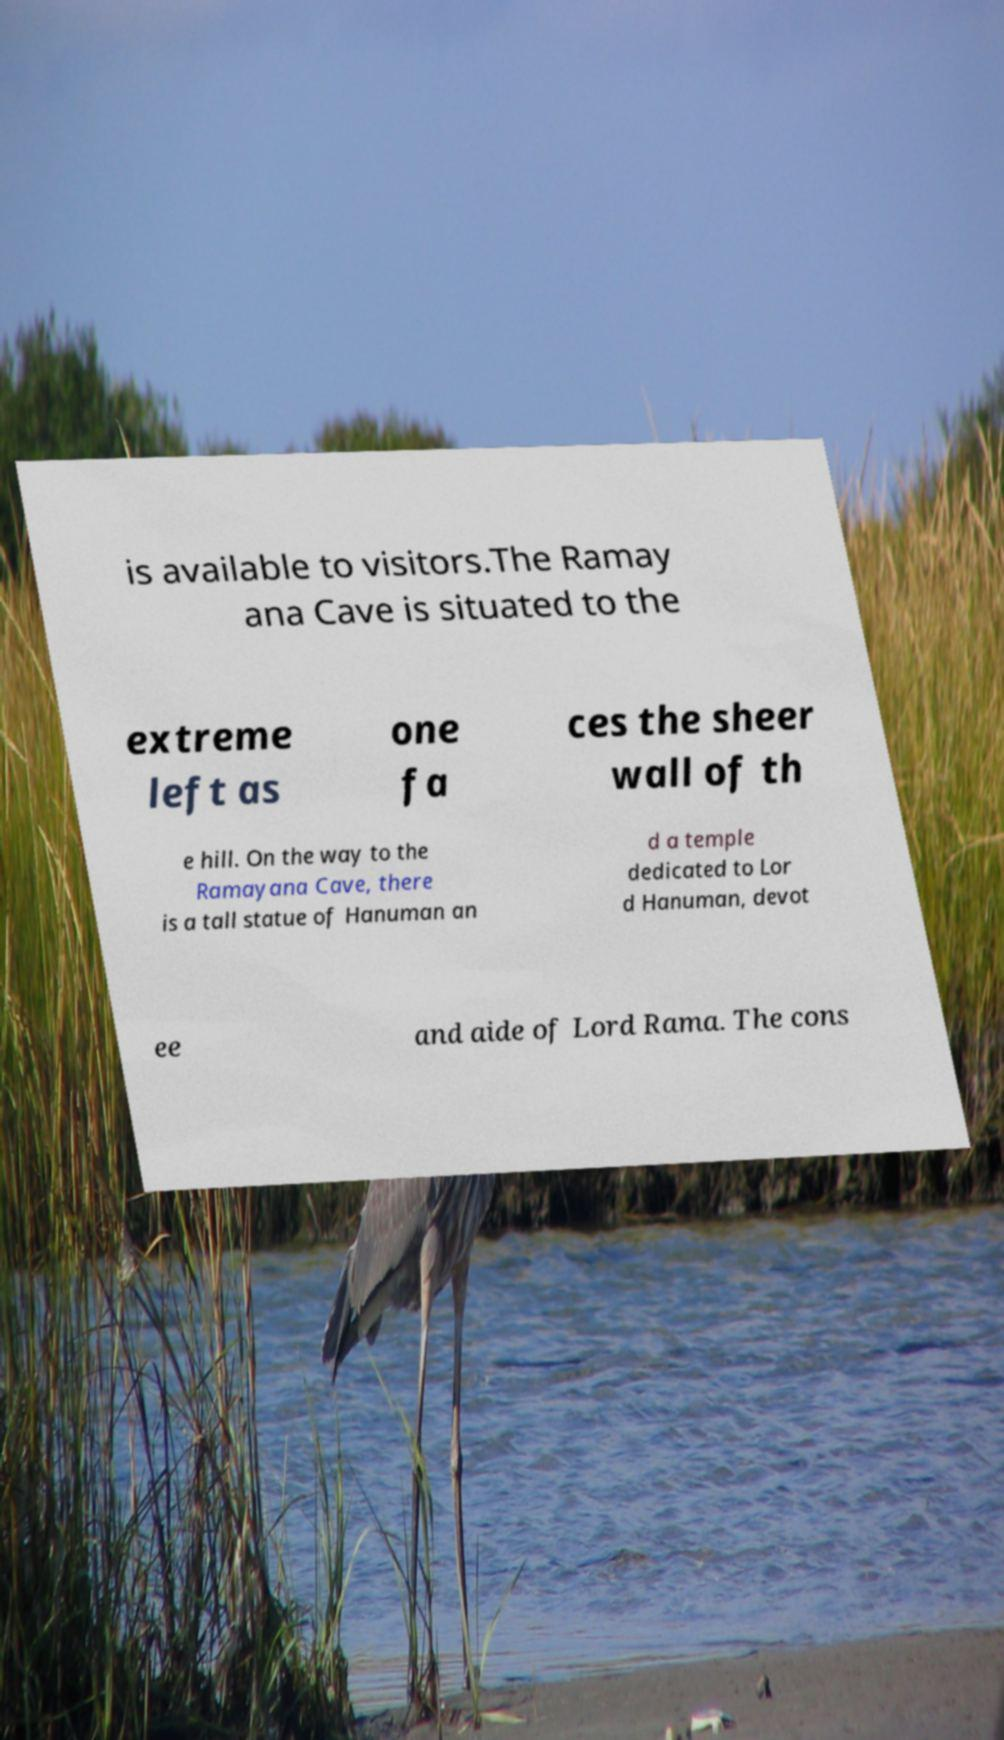For documentation purposes, I need the text within this image transcribed. Could you provide that? is available to visitors.The Ramay ana Cave is situated to the extreme left as one fa ces the sheer wall of th e hill. On the way to the Ramayana Cave, there is a tall statue of Hanuman an d a temple dedicated to Lor d Hanuman, devot ee and aide of Lord Rama. The cons 